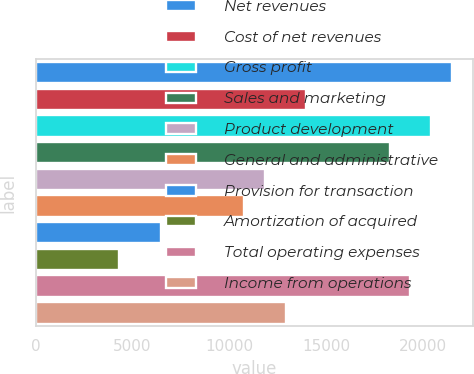Convert chart to OTSL. <chart><loc_0><loc_0><loc_500><loc_500><bar_chart><fcel>Net revenues<fcel>Cost of net revenues<fcel>Gross profit<fcel>Sales and marketing<fcel>Product development<fcel>General and administrative<fcel>Provision for transaction<fcel>Amortization of acquired<fcel>Total operating expenses<fcel>Income from operations<nl><fcel>21490<fcel>13969.2<fcel>20415.6<fcel>18266.8<fcel>11820.4<fcel>10746<fcel>6448.4<fcel>4299.6<fcel>19341.2<fcel>12894.8<nl></chart> 